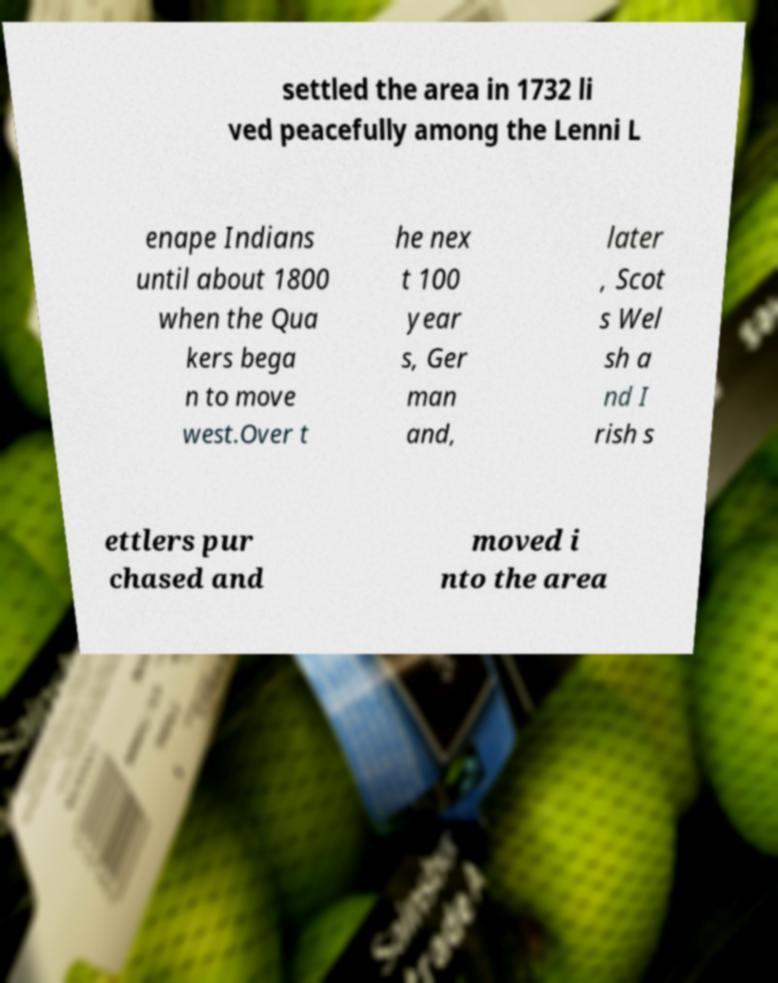There's text embedded in this image that I need extracted. Can you transcribe it verbatim? settled the area in 1732 li ved peacefully among the Lenni L enape Indians until about 1800 when the Qua kers bega n to move west.Over t he nex t 100 year s, Ger man and, later , Scot s Wel sh a nd I rish s ettlers pur chased and moved i nto the area 